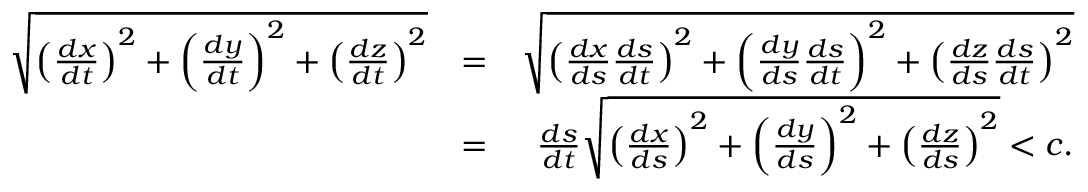<formula> <loc_0><loc_0><loc_500><loc_500>\begin{array} { r l r } { \sqrt { \left ( \frac { d x } { d t } \right ) ^ { 2 } + \left ( \frac { d y } { d t } \right ) ^ { 2 } + \left ( \frac { d z } { d t } \right ) ^ { 2 } } } & { = } & { \sqrt { \left ( \frac { d x } { d s } \frac { d s } { d t } \right ) ^ { 2 } + \left ( \frac { d y } { d s } \frac { d s } { d t } \right ) ^ { 2 } + \left ( \frac { d z } { d s } \frac { d s } { d t } \right ) ^ { 2 } } } \\ & { = } & { \frac { d s } { d t } \sqrt { \left ( \frac { d x } { d s } \right ) ^ { 2 } + \left ( \frac { d y } { d s } \right ) ^ { 2 } + \left ( \frac { d z } { d s } \right ) ^ { 2 } } < c . } \end{array}</formula> 